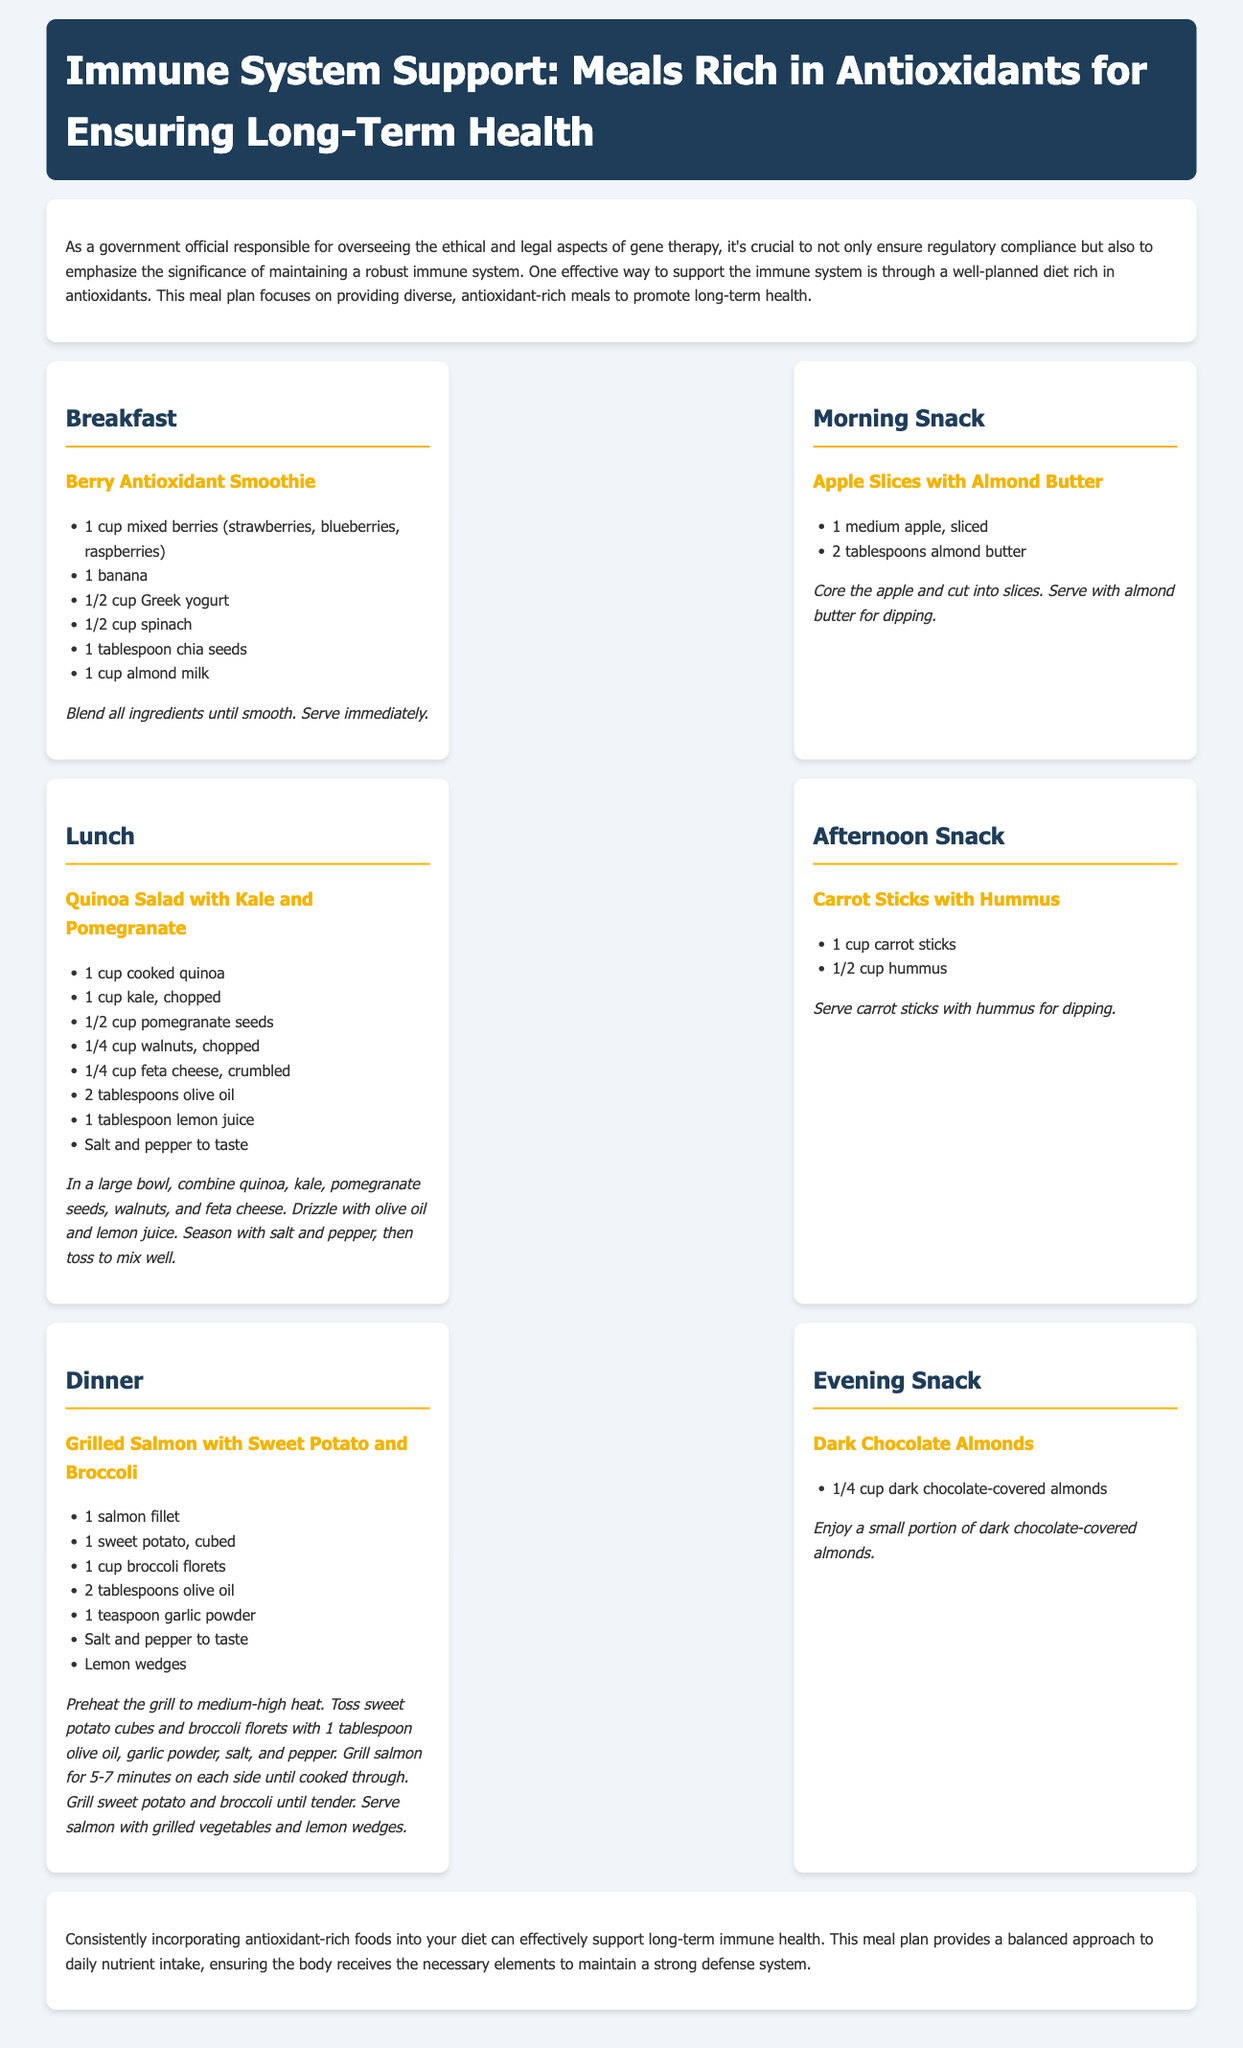what is the title of the meal plan? The title of the meal plan is stated at the top of the document in the header.
Answer: Immune System Support: Meals Rich in Antioxidants for Ensuring Long-Term Health how many meals are included in the plan? The number of meals can be counted in the meal plan section of the document.
Answer: 6 what is one ingredient in the Berry Antioxidant Smoothie? The Berry Antioxidant Smoothie ingredients are listed in the meal section.
Answer: mixed berries what type of salad is included in the lunch meal? The type of salad can be identified from the lunch meal description.
Answer: Quinoa Salad with Kale and Pomegranate which meal includes dark chocolate? The specific meal is mentioned in the evening snack section of the document.
Answer: Evening Snack what are the vegetables served with the grilled salmon? The vegetables are listed in the dinner meal section of the document.
Answer: Sweet Potato and Broccoli how many tablespoons of almond butter are in the morning snack? The amount is specified in the morning snack ingredient list.
Answer: 2 tablespoons what is the main protein source for dinner? The main protein source is highlighted in the dinner meal description.
Answer: Salmon 